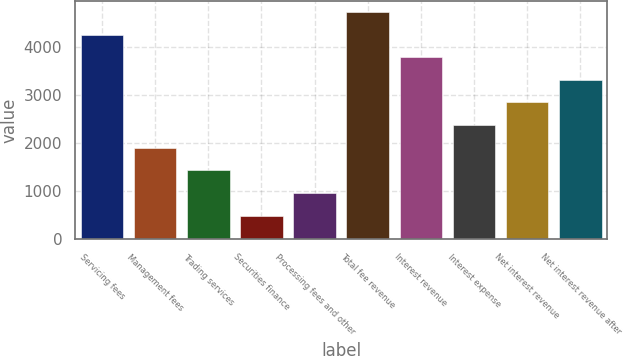Convert chart to OTSL. <chart><loc_0><loc_0><loc_500><loc_500><bar_chart><fcel>Servicing fees<fcel>Management fees<fcel>Trading services<fcel>Securities finance<fcel>Processing fees and other<fcel>Total fee revenue<fcel>Interest revenue<fcel>Interest expense<fcel>Net interest revenue<fcel>Net interest revenue after<nl><fcel>4262.9<fcel>1907.4<fcel>1436.3<fcel>494.1<fcel>965.2<fcel>4734<fcel>3791.8<fcel>2378.5<fcel>2849.6<fcel>3320.7<nl></chart> 